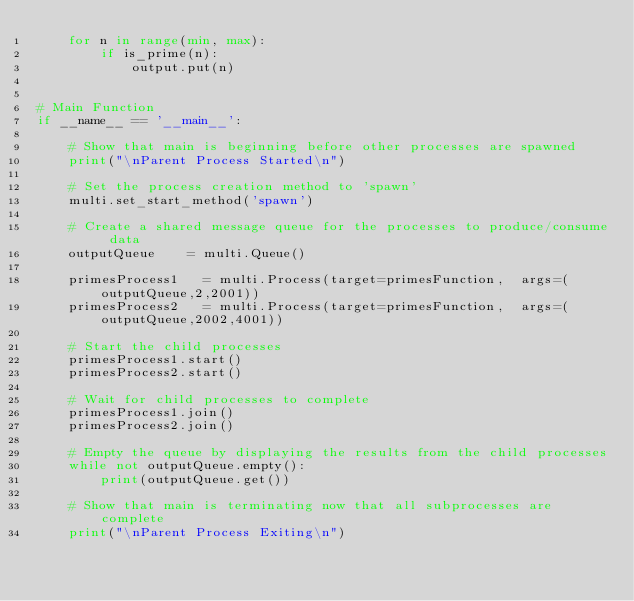Convert code to text. <code><loc_0><loc_0><loc_500><loc_500><_Python_>    for n in range(min, max):
        if is_prime(n):
            output.put(n)


# Main Function
if __name__ == '__main__':

    # Show that main is beginning before other processes are spawned
    print("\nParent Process Started\n")

    # Set the process creation method to 'spawn'
    multi.set_start_method('spawn')

    # Create a shared message queue for the processes to produce/consume data
    outputQueue    = multi.Queue()

    primesProcess1   = multi.Process(target=primesFunction,  args=(outputQueue,2,2001))
    primesProcess2   = multi.Process(target=primesFunction,  args=(outputQueue,2002,4001))

    # Start the child processes
    primesProcess1.start()
    primesProcess2.start()

    # Wait for child processes to complete
    primesProcess1.join()
    primesProcess2.join()

    # Empty the queue by displaying the results from the child processes
    while not outputQueue.empty():
        print(outputQueue.get())

    # Show that main is terminating now that all subprocesses are complete
    print("\nParent Process Exiting\n")</code> 